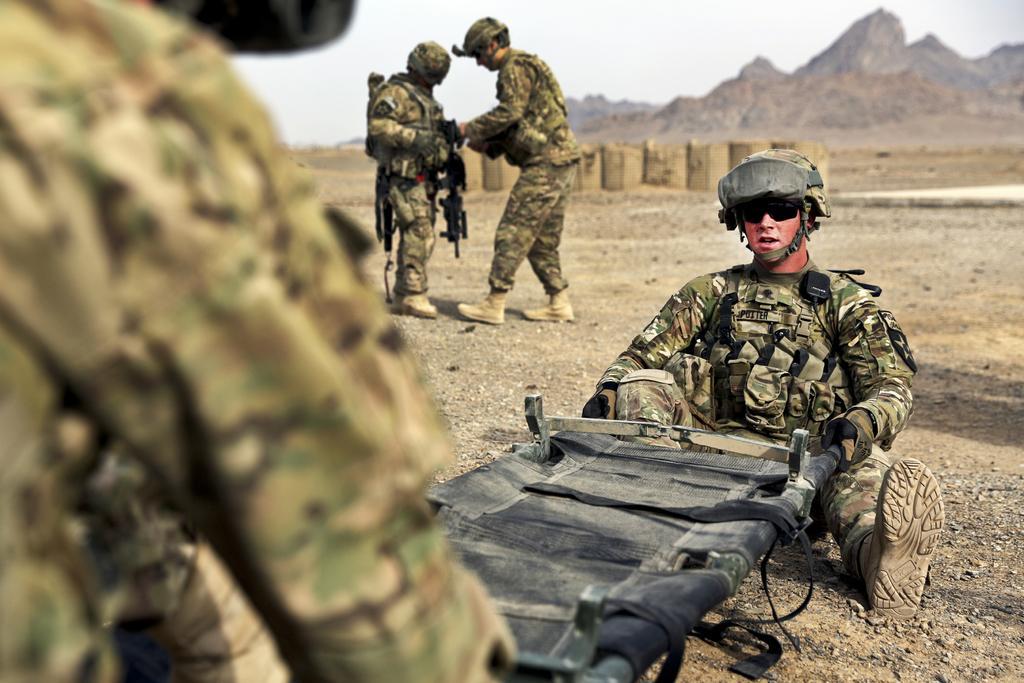How would you summarize this image in a sentence or two? This is an outside view. In this image I can see four men wearing uniforms and caps on their heads. Two men are holding a black color object in their hands. Two men are standing and holding the guns. In the background there is a wall and mountains. At the top of the image I can see the sky. 